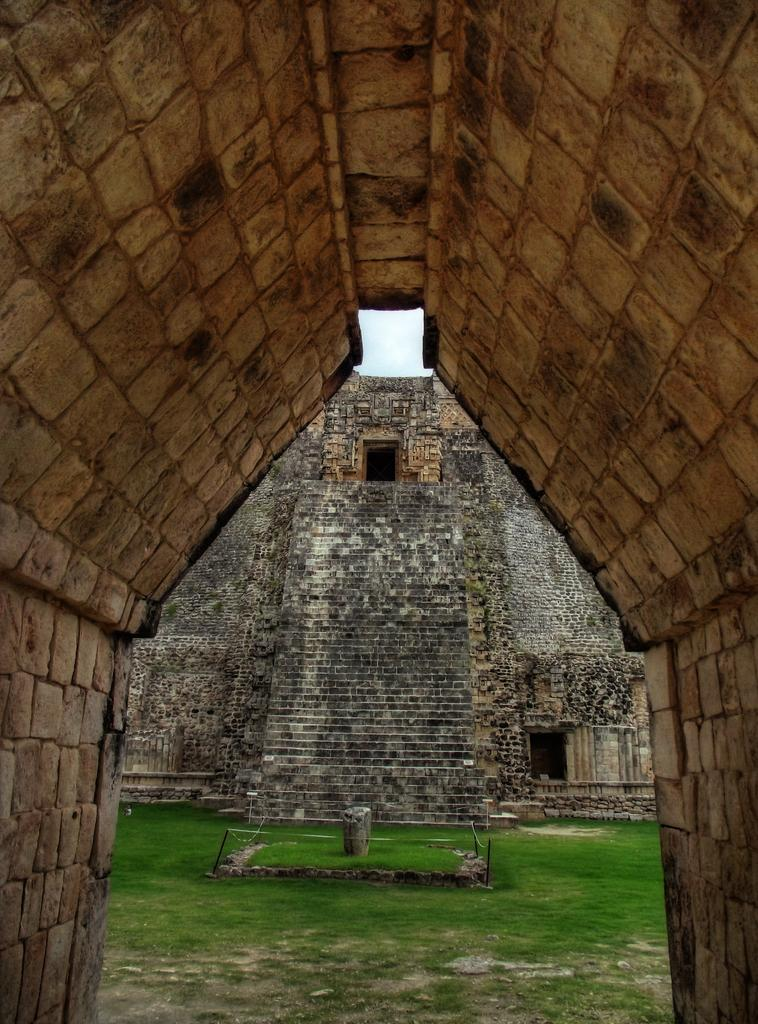What is the main subject of the image? The main subject of the image is a pyramid of the magician. Can you describe any specific features of the pyramid? The pyramid appears to be made of a triangular archway. How much does the cat weigh in the image? There is no cat present in the image, so it is not possible to determine its weight. 